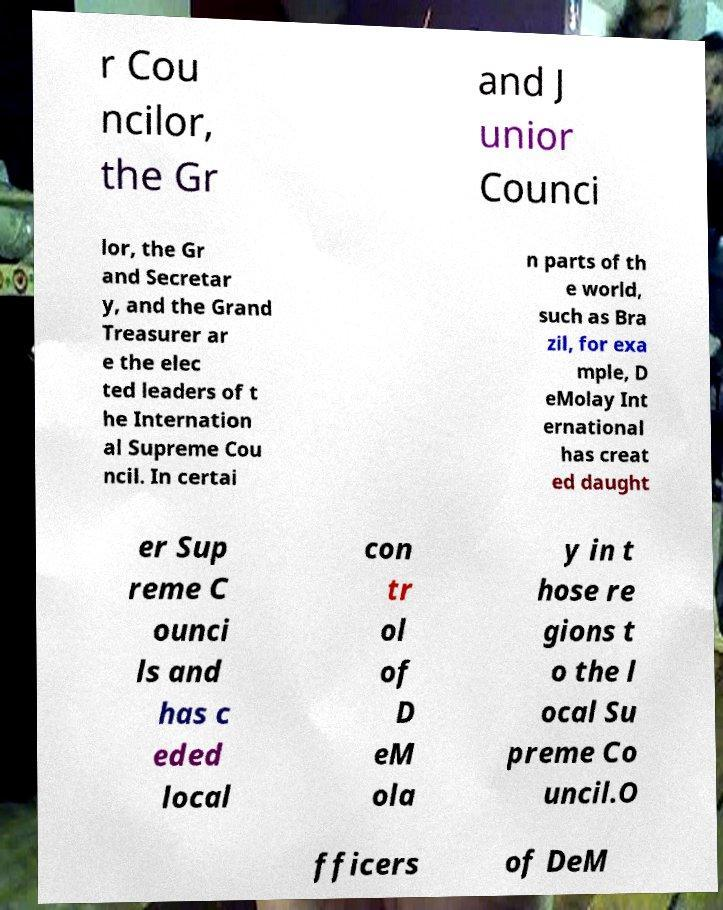Could you extract and type out the text from this image? r Cou ncilor, the Gr and J unior Counci lor, the Gr and Secretar y, and the Grand Treasurer ar e the elec ted leaders of t he Internation al Supreme Cou ncil. In certai n parts of th e world, such as Bra zil, for exa mple, D eMolay Int ernational has creat ed daught er Sup reme C ounci ls and has c eded local con tr ol of D eM ola y in t hose re gions t o the l ocal Su preme Co uncil.O fficers of DeM 